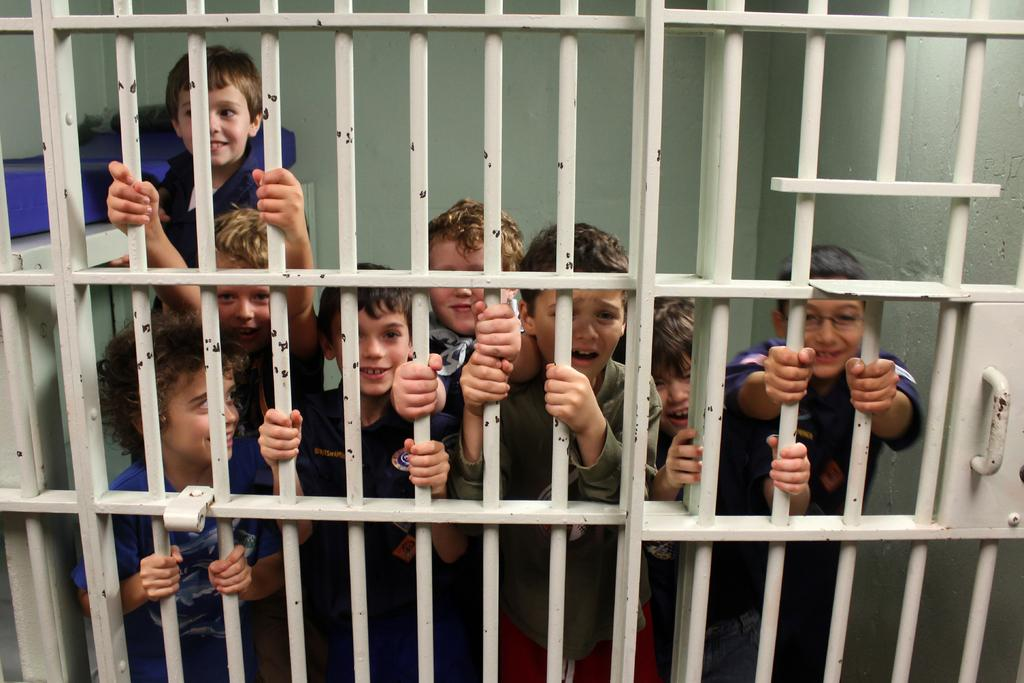What can be seen in the image? There are children in the image. What are the children doing? The children are standing. What is in front of the children? There is a gate in front of the children. What type of glue is being used by the children in the image? There is no glue present in the image; the children are simply standing. What country are the children from in the image? The image does not provide information about the children's nationality or the country they are in. 